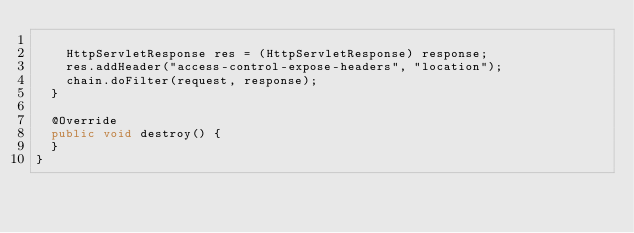Convert code to text. <code><loc_0><loc_0><loc_500><loc_500><_Java_>
		HttpServletResponse res = (HttpServletResponse) response;
		res.addHeader("access-control-expose-headers", "location");
		chain.doFilter(request, response);
	}

	@Override
	public void destroy() {
	}
}</code> 